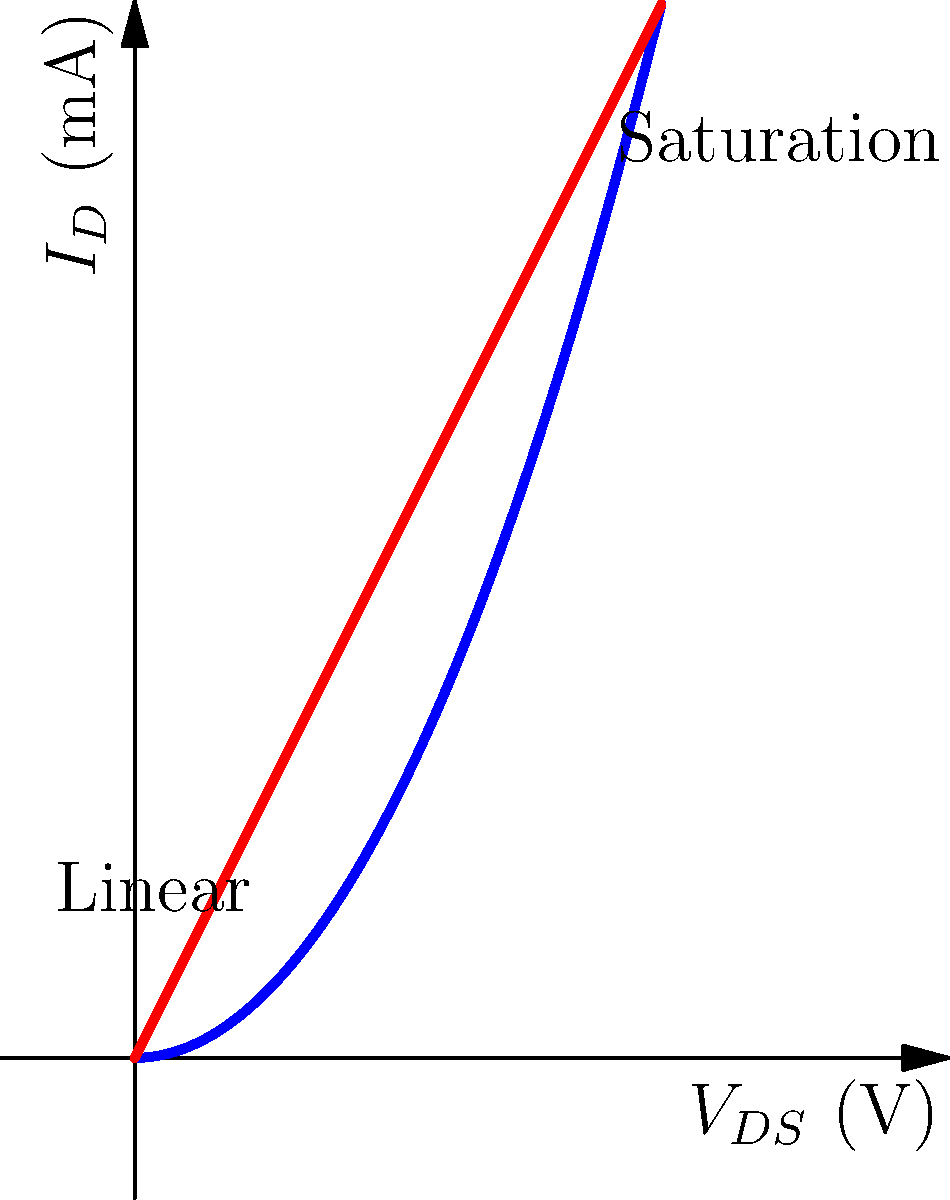Based on the I-V characteristic curves of a transistor shown above, what can you conclude about the transistor's behavior when $V_{GS} = 3V$ and $V_{DS} = 2V$? How would this information be relevant for designing a circuit using this transistor in a Singer Instruments product? To interpret the transistor's behavior and its relevance to product design, let's analyze the I-V curves step-by-step:

1. Identify the curves: The blue curve represents $V_{GS} = 3V$, and the red curve represents $V_{GS} = 2V$.

2. Locate the point of interest: We need to focus on the blue curve ($V_{GS} = 3V$) at $V_{DS} = 2V$.

3. Analyze the curve shape: The blue curve shows two distinct regions:
   a) Linear region: The initial part where current increases linearly with $V_{DS}$.
   b) Saturation region: The latter part where current remains relatively constant as $V_{DS}$ increases.

4. Determine the operating point: At $V_{DS} = 2V$ on the blue curve, the transistor is operating in the saturation region.

5. Interpret the behavior: In the saturation region, the drain current ($I_D$) remains relatively constant despite changes in $V_{DS}$. This indicates that the transistor is acting as a current source.

6. Relevance to product design:
   a) Amplification: The saturation region is ideal for designing amplifier circuits, as small changes in input voltage ($V_{GS}$) result in significant changes in output current ($I_D$).
   b) Stability: The constant current characteristic in saturation provides stability in circuit operation, which is crucial for precise measurements in scientific instruments.
   c) Power efficiency: Operating in saturation allows for better control of power consumption, which is important for portable or battery-operated devices.
   d) Signal processing: The predictable behavior in saturation is useful for designing signal processing circuits, which could be relevant for data acquisition or sensor interfacing in Singer Instruments products.

Understanding these characteristics allows product managers to collaborate effectively with research scientists to optimize circuit designs, improve product performance, and enhance features that rely on transistor behavior.
Answer: The transistor is operating in the saturation region, acting as a current source, which is useful for designing stable amplifiers and efficient signal processing circuits in scientific instruments. 